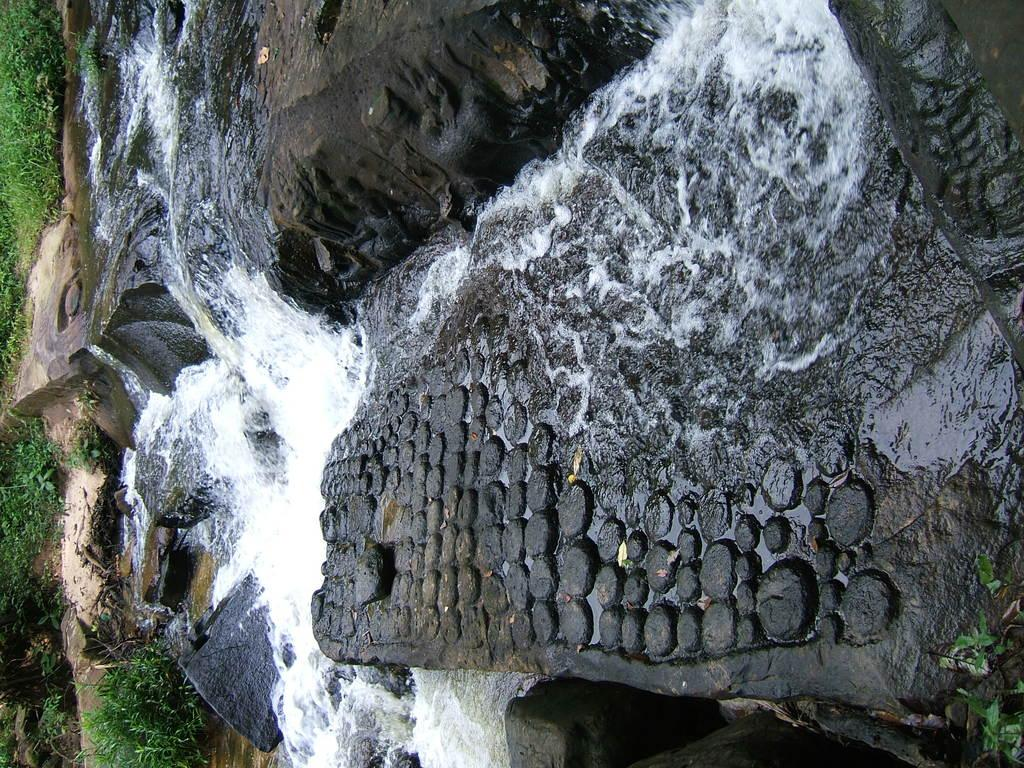What is the main feature of the image? The main feature of the image is a water flow. What can be seen on the left side of the image? There is grass on the left side of the image. What type of marble is being used for the operation in the image? There is no marble or operation present in the image; it features a water flow and grass. Can you see a robin in the image? There is no robin present in the image. 